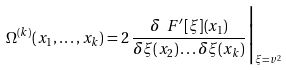Convert formula to latex. <formula><loc_0><loc_0><loc_500><loc_500>\Omega ^ { ( k ) } ( x _ { 1 } , \dots , x _ { k } ) = 2 \, \frac { \delta \ F ^ { \prime } [ \xi ] ( x _ { 1 } ) } { \delta \xi ( x _ { 2 } ) \dots \delta \xi ( x _ { k } ) } \Big | _ { \xi = v ^ { 2 } }</formula> 